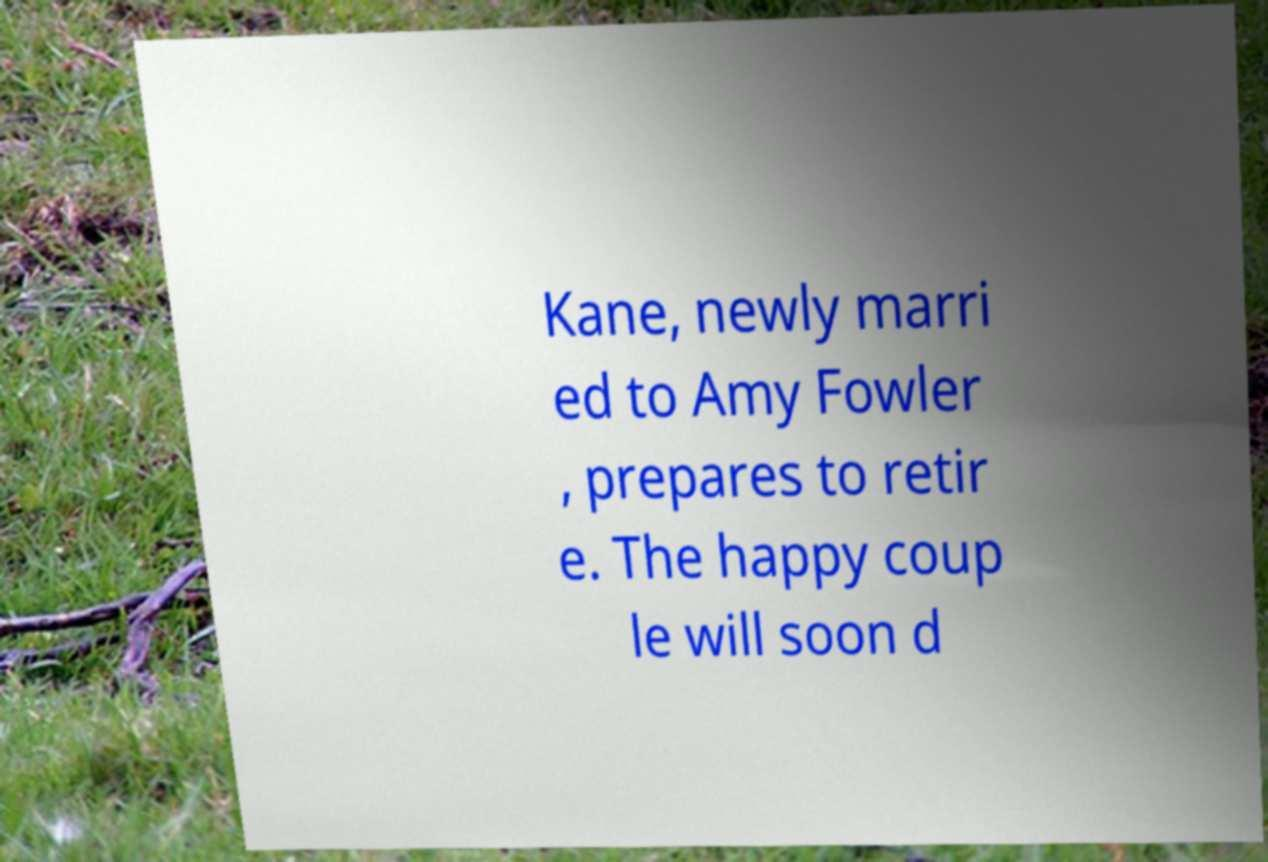What messages or text are displayed in this image? I need them in a readable, typed format. Kane, newly marri ed to Amy Fowler , prepares to retir e. The happy coup le will soon d 